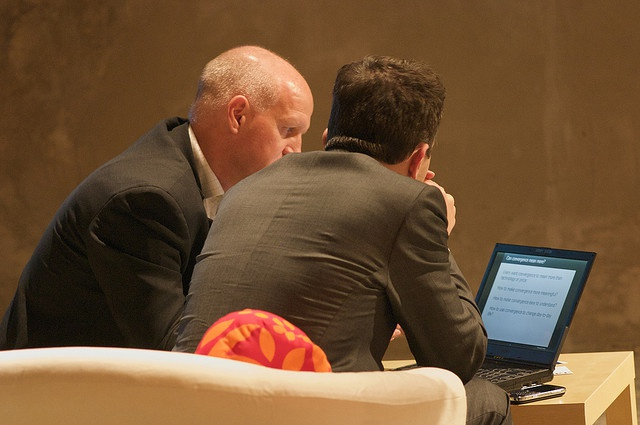Describe the objects in this image and their specific colors. I can see people in maroon, black, and gray tones, people in maroon, black, and brown tones, couch in maroon, tan, and ivory tones, laptop in maroon, black, gray, lightblue, and darkgray tones, and dining table in maroon, tan, and brown tones in this image. 